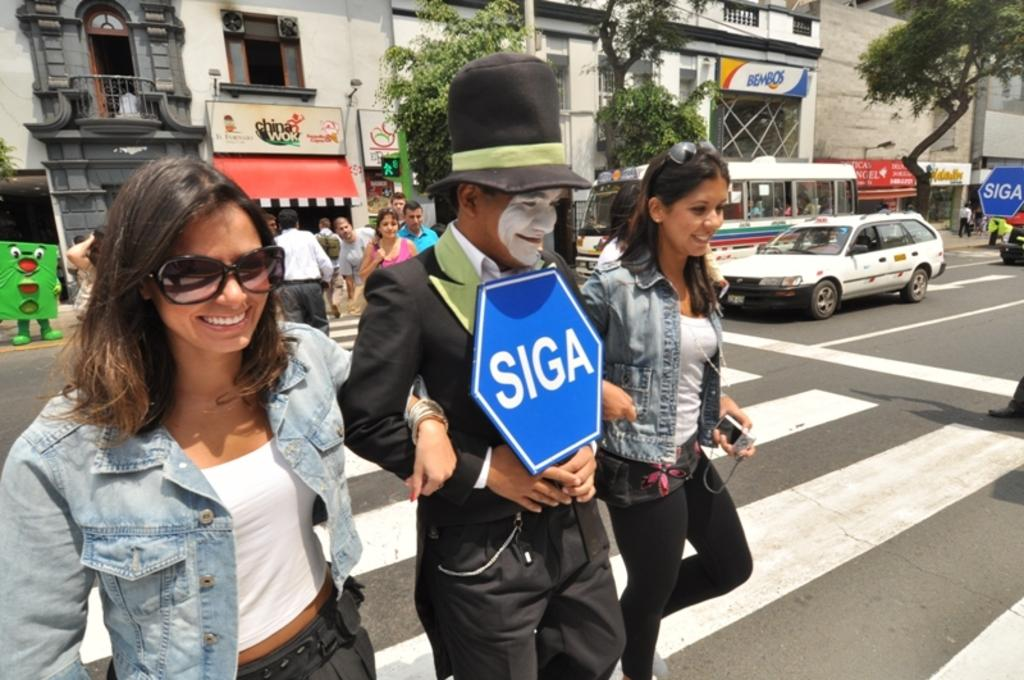What can be seen in the image? There are many buildings visible in the image. Where are the buildings located in relation to the road? The buildings are beside a road. What is happening on the road? There are people walking on the road. What type of loaf can be seen being carried by someone on the road? There is no loaf present in the image, and therefore no such activity can be observed. How does the chalk help the people walking on the road? There is no mention of chalk in the image, so it cannot be determined how it might help the people walking on the road. 